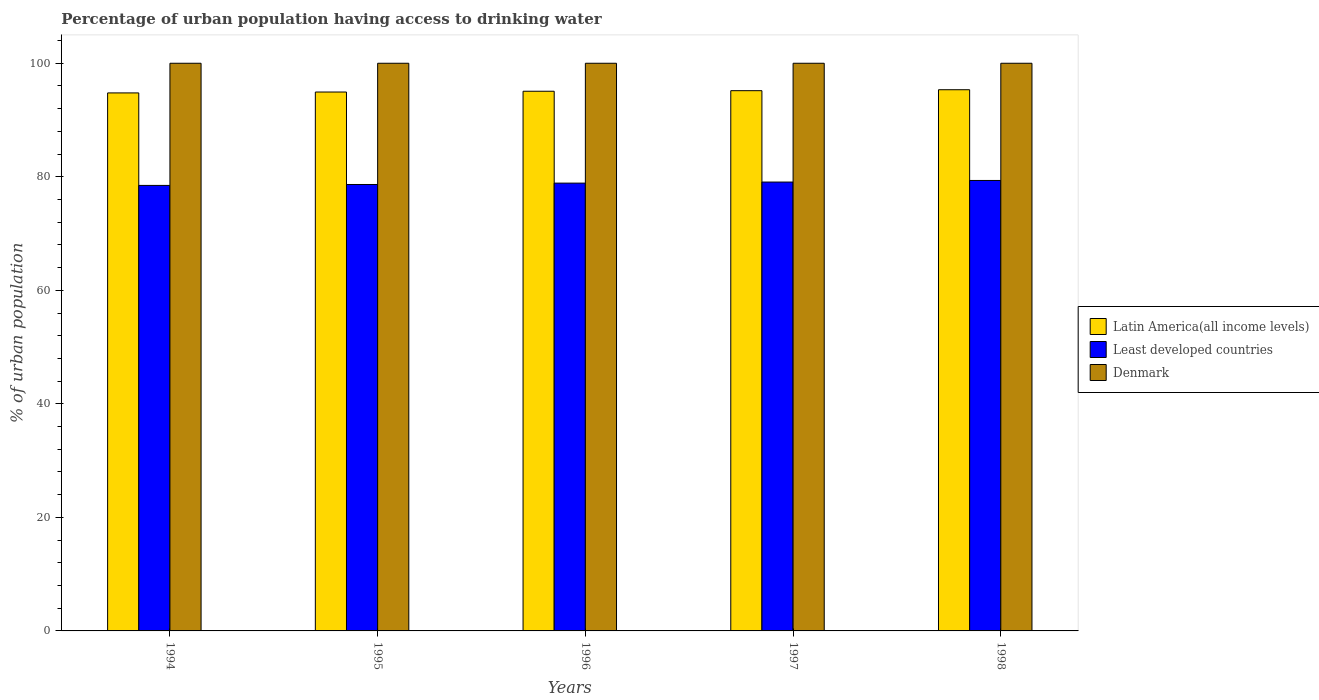How many different coloured bars are there?
Your answer should be very brief. 3. How many groups of bars are there?
Provide a succinct answer. 5. How many bars are there on the 3rd tick from the left?
Offer a very short reply. 3. How many bars are there on the 5th tick from the right?
Give a very brief answer. 3. In how many cases, is the number of bars for a given year not equal to the number of legend labels?
Provide a short and direct response. 0. What is the percentage of urban population having access to drinking water in Least developed countries in 1997?
Your response must be concise. 79.07. Across all years, what is the maximum percentage of urban population having access to drinking water in Denmark?
Ensure brevity in your answer.  100. Across all years, what is the minimum percentage of urban population having access to drinking water in Denmark?
Your answer should be very brief. 100. In which year was the percentage of urban population having access to drinking water in Latin America(all income levels) maximum?
Your answer should be compact. 1998. In which year was the percentage of urban population having access to drinking water in Least developed countries minimum?
Provide a succinct answer. 1994. What is the total percentage of urban population having access to drinking water in Denmark in the graph?
Make the answer very short. 500. What is the difference between the percentage of urban population having access to drinking water in Latin America(all income levels) in 1994 and the percentage of urban population having access to drinking water in Denmark in 1995?
Make the answer very short. -5.22. What is the average percentage of urban population having access to drinking water in Latin America(all income levels) per year?
Provide a short and direct response. 95.06. In the year 1998, what is the difference between the percentage of urban population having access to drinking water in Least developed countries and percentage of urban population having access to drinking water in Latin America(all income levels)?
Your answer should be very brief. -15.98. What is the ratio of the percentage of urban population having access to drinking water in Latin America(all income levels) in 1994 to that in 1997?
Provide a succinct answer. 1. What is the difference between the highest and the second highest percentage of urban population having access to drinking water in Denmark?
Keep it short and to the point. 0. What is the difference between the highest and the lowest percentage of urban population having access to drinking water in Least developed countries?
Make the answer very short. 0.87. Is the sum of the percentage of urban population having access to drinking water in Least developed countries in 1997 and 1998 greater than the maximum percentage of urban population having access to drinking water in Latin America(all income levels) across all years?
Offer a terse response. Yes. What does the 1st bar from the left in 1996 represents?
Provide a succinct answer. Latin America(all income levels). What does the 2nd bar from the right in 1998 represents?
Give a very brief answer. Least developed countries. Is it the case that in every year, the sum of the percentage of urban population having access to drinking water in Denmark and percentage of urban population having access to drinking water in Latin America(all income levels) is greater than the percentage of urban population having access to drinking water in Least developed countries?
Keep it short and to the point. Yes. Are all the bars in the graph horizontal?
Provide a succinct answer. No. What is the difference between two consecutive major ticks on the Y-axis?
Make the answer very short. 20. Does the graph contain grids?
Your response must be concise. No. Where does the legend appear in the graph?
Make the answer very short. Center right. How are the legend labels stacked?
Ensure brevity in your answer.  Vertical. What is the title of the graph?
Keep it short and to the point. Percentage of urban population having access to drinking water. Does "Lithuania" appear as one of the legend labels in the graph?
Offer a terse response. No. What is the label or title of the Y-axis?
Offer a very short reply. % of urban population. What is the % of urban population in Latin America(all income levels) in 1994?
Provide a short and direct response. 94.78. What is the % of urban population in Least developed countries in 1994?
Your response must be concise. 78.48. What is the % of urban population in Denmark in 1994?
Make the answer very short. 100. What is the % of urban population of Latin America(all income levels) in 1995?
Ensure brevity in your answer.  94.93. What is the % of urban population of Least developed countries in 1995?
Your answer should be very brief. 78.64. What is the % of urban population in Denmark in 1995?
Offer a very short reply. 100. What is the % of urban population in Latin America(all income levels) in 1996?
Offer a very short reply. 95.07. What is the % of urban population of Least developed countries in 1996?
Keep it short and to the point. 78.88. What is the % of urban population of Latin America(all income levels) in 1997?
Offer a very short reply. 95.17. What is the % of urban population in Least developed countries in 1997?
Your response must be concise. 79.07. What is the % of urban population in Denmark in 1997?
Offer a very short reply. 100. What is the % of urban population in Latin America(all income levels) in 1998?
Offer a very short reply. 95.34. What is the % of urban population of Least developed countries in 1998?
Your answer should be compact. 79.35. Across all years, what is the maximum % of urban population of Latin America(all income levels)?
Offer a very short reply. 95.34. Across all years, what is the maximum % of urban population of Least developed countries?
Make the answer very short. 79.35. Across all years, what is the minimum % of urban population in Latin America(all income levels)?
Your answer should be compact. 94.78. Across all years, what is the minimum % of urban population of Least developed countries?
Give a very brief answer. 78.48. Across all years, what is the minimum % of urban population in Denmark?
Your answer should be compact. 100. What is the total % of urban population of Latin America(all income levels) in the graph?
Your answer should be very brief. 475.29. What is the total % of urban population in Least developed countries in the graph?
Make the answer very short. 394.44. What is the difference between the % of urban population in Latin America(all income levels) in 1994 and that in 1995?
Your answer should be very brief. -0.16. What is the difference between the % of urban population of Least developed countries in 1994 and that in 1995?
Make the answer very short. -0.16. What is the difference between the % of urban population in Latin America(all income levels) in 1994 and that in 1996?
Provide a short and direct response. -0.3. What is the difference between the % of urban population in Least developed countries in 1994 and that in 1996?
Offer a very short reply. -0.4. What is the difference between the % of urban population in Denmark in 1994 and that in 1996?
Keep it short and to the point. 0. What is the difference between the % of urban population in Latin America(all income levels) in 1994 and that in 1997?
Give a very brief answer. -0.39. What is the difference between the % of urban population in Least developed countries in 1994 and that in 1997?
Your answer should be very brief. -0.59. What is the difference between the % of urban population of Denmark in 1994 and that in 1997?
Keep it short and to the point. 0. What is the difference between the % of urban population in Latin America(all income levels) in 1994 and that in 1998?
Your answer should be compact. -0.56. What is the difference between the % of urban population in Least developed countries in 1994 and that in 1998?
Your answer should be very brief. -0.87. What is the difference between the % of urban population in Latin America(all income levels) in 1995 and that in 1996?
Your answer should be very brief. -0.14. What is the difference between the % of urban population of Least developed countries in 1995 and that in 1996?
Your response must be concise. -0.24. What is the difference between the % of urban population in Denmark in 1995 and that in 1996?
Provide a short and direct response. 0. What is the difference between the % of urban population of Latin America(all income levels) in 1995 and that in 1997?
Your answer should be compact. -0.24. What is the difference between the % of urban population in Least developed countries in 1995 and that in 1997?
Give a very brief answer. -0.43. What is the difference between the % of urban population of Denmark in 1995 and that in 1997?
Provide a succinct answer. 0. What is the difference between the % of urban population in Latin America(all income levels) in 1995 and that in 1998?
Your response must be concise. -0.4. What is the difference between the % of urban population of Least developed countries in 1995 and that in 1998?
Your answer should be very brief. -0.71. What is the difference between the % of urban population in Denmark in 1995 and that in 1998?
Your answer should be very brief. 0. What is the difference between the % of urban population of Latin America(all income levels) in 1996 and that in 1997?
Your answer should be very brief. -0.1. What is the difference between the % of urban population of Least developed countries in 1996 and that in 1997?
Provide a succinct answer. -0.19. What is the difference between the % of urban population of Denmark in 1996 and that in 1997?
Make the answer very short. 0. What is the difference between the % of urban population in Latin America(all income levels) in 1996 and that in 1998?
Offer a terse response. -0.27. What is the difference between the % of urban population of Least developed countries in 1996 and that in 1998?
Your answer should be compact. -0.47. What is the difference between the % of urban population in Denmark in 1996 and that in 1998?
Your answer should be compact. 0. What is the difference between the % of urban population of Latin America(all income levels) in 1997 and that in 1998?
Provide a short and direct response. -0.17. What is the difference between the % of urban population of Least developed countries in 1997 and that in 1998?
Offer a terse response. -0.28. What is the difference between the % of urban population of Latin America(all income levels) in 1994 and the % of urban population of Least developed countries in 1995?
Provide a succinct answer. 16.13. What is the difference between the % of urban population of Latin America(all income levels) in 1994 and the % of urban population of Denmark in 1995?
Ensure brevity in your answer.  -5.22. What is the difference between the % of urban population of Least developed countries in 1994 and the % of urban population of Denmark in 1995?
Keep it short and to the point. -21.52. What is the difference between the % of urban population in Latin America(all income levels) in 1994 and the % of urban population in Least developed countries in 1996?
Make the answer very short. 15.89. What is the difference between the % of urban population in Latin America(all income levels) in 1994 and the % of urban population in Denmark in 1996?
Offer a very short reply. -5.22. What is the difference between the % of urban population of Least developed countries in 1994 and the % of urban population of Denmark in 1996?
Offer a very short reply. -21.52. What is the difference between the % of urban population of Latin America(all income levels) in 1994 and the % of urban population of Least developed countries in 1997?
Give a very brief answer. 15.7. What is the difference between the % of urban population in Latin America(all income levels) in 1994 and the % of urban population in Denmark in 1997?
Your answer should be very brief. -5.22. What is the difference between the % of urban population of Least developed countries in 1994 and the % of urban population of Denmark in 1997?
Provide a short and direct response. -21.52. What is the difference between the % of urban population of Latin America(all income levels) in 1994 and the % of urban population of Least developed countries in 1998?
Provide a succinct answer. 15.42. What is the difference between the % of urban population in Latin America(all income levels) in 1994 and the % of urban population in Denmark in 1998?
Make the answer very short. -5.22. What is the difference between the % of urban population of Least developed countries in 1994 and the % of urban population of Denmark in 1998?
Your response must be concise. -21.52. What is the difference between the % of urban population in Latin America(all income levels) in 1995 and the % of urban population in Least developed countries in 1996?
Your answer should be compact. 16.05. What is the difference between the % of urban population in Latin America(all income levels) in 1995 and the % of urban population in Denmark in 1996?
Give a very brief answer. -5.07. What is the difference between the % of urban population in Least developed countries in 1995 and the % of urban population in Denmark in 1996?
Ensure brevity in your answer.  -21.36. What is the difference between the % of urban population in Latin America(all income levels) in 1995 and the % of urban population in Least developed countries in 1997?
Give a very brief answer. 15.86. What is the difference between the % of urban population in Latin America(all income levels) in 1995 and the % of urban population in Denmark in 1997?
Offer a terse response. -5.07. What is the difference between the % of urban population in Least developed countries in 1995 and the % of urban population in Denmark in 1997?
Ensure brevity in your answer.  -21.36. What is the difference between the % of urban population in Latin America(all income levels) in 1995 and the % of urban population in Least developed countries in 1998?
Your response must be concise. 15.58. What is the difference between the % of urban population of Latin America(all income levels) in 1995 and the % of urban population of Denmark in 1998?
Your response must be concise. -5.07. What is the difference between the % of urban population of Least developed countries in 1995 and the % of urban population of Denmark in 1998?
Your answer should be very brief. -21.36. What is the difference between the % of urban population in Latin America(all income levels) in 1996 and the % of urban population in Least developed countries in 1997?
Your answer should be compact. 16. What is the difference between the % of urban population of Latin America(all income levels) in 1996 and the % of urban population of Denmark in 1997?
Ensure brevity in your answer.  -4.93. What is the difference between the % of urban population of Least developed countries in 1996 and the % of urban population of Denmark in 1997?
Your answer should be very brief. -21.11. What is the difference between the % of urban population in Latin America(all income levels) in 1996 and the % of urban population in Least developed countries in 1998?
Your response must be concise. 15.72. What is the difference between the % of urban population in Latin America(all income levels) in 1996 and the % of urban population in Denmark in 1998?
Give a very brief answer. -4.93. What is the difference between the % of urban population in Least developed countries in 1996 and the % of urban population in Denmark in 1998?
Keep it short and to the point. -21.11. What is the difference between the % of urban population of Latin America(all income levels) in 1997 and the % of urban population of Least developed countries in 1998?
Provide a short and direct response. 15.81. What is the difference between the % of urban population of Latin America(all income levels) in 1997 and the % of urban population of Denmark in 1998?
Your answer should be compact. -4.83. What is the difference between the % of urban population of Least developed countries in 1997 and the % of urban population of Denmark in 1998?
Offer a very short reply. -20.93. What is the average % of urban population in Latin America(all income levels) per year?
Keep it short and to the point. 95.06. What is the average % of urban population of Least developed countries per year?
Provide a short and direct response. 78.89. What is the average % of urban population of Denmark per year?
Your answer should be compact. 100. In the year 1994, what is the difference between the % of urban population of Latin America(all income levels) and % of urban population of Least developed countries?
Make the answer very short. 16.3. In the year 1994, what is the difference between the % of urban population in Latin America(all income levels) and % of urban population in Denmark?
Your response must be concise. -5.22. In the year 1994, what is the difference between the % of urban population of Least developed countries and % of urban population of Denmark?
Provide a succinct answer. -21.52. In the year 1995, what is the difference between the % of urban population of Latin America(all income levels) and % of urban population of Least developed countries?
Keep it short and to the point. 16.29. In the year 1995, what is the difference between the % of urban population of Latin America(all income levels) and % of urban population of Denmark?
Give a very brief answer. -5.07. In the year 1995, what is the difference between the % of urban population in Least developed countries and % of urban population in Denmark?
Your response must be concise. -21.36. In the year 1996, what is the difference between the % of urban population of Latin America(all income levels) and % of urban population of Least developed countries?
Provide a succinct answer. 16.19. In the year 1996, what is the difference between the % of urban population in Latin America(all income levels) and % of urban population in Denmark?
Your answer should be very brief. -4.93. In the year 1996, what is the difference between the % of urban population of Least developed countries and % of urban population of Denmark?
Ensure brevity in your answer.  -21.11. In the year 1997, what is the difference between the % of urban population of Latin America(all income levels) and % of urban population of Least developed countries?
Keep it short and to the point. 16.1. In the year 1997, what is the difference between the % of urban population of Latin America(all income levels) and % of urban population of Denmark?
Provide a short and direct response. -4.83. In the year 1997, what is the difference between the % of urban population of Least developed countries and % of urban population of Denmark?
Provide a short and direct response. -20.93. In the year 1998, what is the difference between the % of urban population in Latin America(all income levels) and % of urban population in Least developed countries?
Offer a very short reply. 15.98. In the year 1998, what is the difference between the % of urban population of Latin America(all income levels) and % of urban population of Denmark?
Make the answer very short. -4.66. In the year 1998, what is the difference between the % of urban population of Least developed countries and % of urban population of Denmark?
Your answer should be compact. -20.65. What is the ratio of the % of urban population in Denmark in 1994 to that in 1995?
Your answer should be very brief. 1. What is the ratio of the % of urban population of Least developed countries in 1994 to that in 1996?
Make the answer very short. 0.99. What is the ratio of the % of urban population in Latin America(all income levels) in 1994 to that in 1997?
Keep it short and to the point. 1. What is the ratio of the % of urban population of Least developed countries in 1994 to that in 1997?
Your response must be concise. 0.99. What is the ratio of the % of urban population in Denmark in 1994 to that in 1997?
Offer a very short reply. 1. What is the ratio of the % of urban population in Latin America(all income levels) in 1994 to that in 1998?
Your response must be concise. 0.99. What is the ratio of the % of urban population in Least developed countries in 1994 to that in 1998?
Make the answer very short. 0.99. What is the ratio of the % of urban population in Least developed countries in 1995 to that in 1997?
Offer a very short reply. 0.99. What is the ratio of the % of urban population in Denmark in 1995 to that in 1998?
Your answer should be compact. 1. What is the ratio of the % of urban population in Latin America(all income levels) in 1996 to that in 1997?
Provide a succinct answer. 1. What is the ratio of the % of urban population in Least developed countries in 1996 to that in 1997?
Ensure brevity in your answer.  1. What is the ratio of the % of urban population of Latin America(all income levels) in 1996 to that in 1998?
Offer a terse response. 1. What is the ratio of the % of urban population of Denmark in 1996 to that in 1998?
Provide a short and direct response. 1. What is the ratio of the % of urban population in Latin America(all income levels) in 1997 to that in 1998?
Offer a terse response. 1. What is the ratio of the % of urban population of Least developed countries in 1997 to that in 1998?
Your response must be concise. 1. What is the difference between the highest and the second highest % of urban population in Latin America(all income levels)?
Ensure brevity in your answer.  0.17. What is the difference between the highest and the second highest % of urban population in Least developed countries?
Your answer should be very brief. 0.28. What is the difference between the highest and the lowest % of urban population in Latin America(all income levels)?
Give a very brief answer. 0.56. What is the difference between the highest and the lowest % of urban population of Least developed countries?
Make the answer very short. 0.87. What is the difference between the highest and the lowest % of urban population in Denmark?
Provide a succinct answer. 0. 